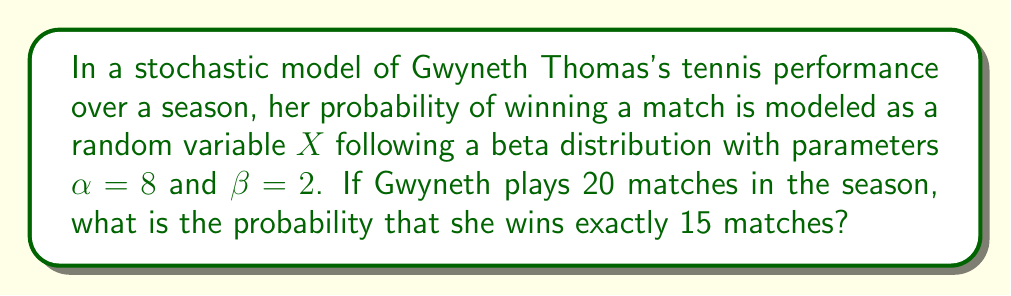Solve this math problem. To solve this problem, we need to use the concept of a beta-binomial distribution, which is a combination of the beta and binomial distributions. Here's the step-by-step solution:

1) The beta distribution models Gwyneth's probability of winning a single match. The mean of this distribution is:

   $$E[X] = \frac{\alpha}{\alpha + \beta} = \frac{8}{8 + 2} = 0.8$$

2) The number of wins in 20 matches, given the probability of winning each match, follows a binomial distribution. However, since the probability itself is a random variable, we need to use the beta-binomial distribution.

3) The probability mass function of the beta-binomial distribution is:

   $$P(Y = k) = \binom{n}{k} \frac{B(k + \alpha, n - k + \beta)}{B(\alpha, \beta)}$$

   where $B(a,b)$ is the beta function, $n$ is the number of trials, and $k$ is the number of successes.

4) In this case, $n = 20$, $k = 15$, $\alpha = 8$, and $\beta = 2$.

5) Substituting these values:

   $$P(Y = 15) = \binom{20}{15} \frac{B(15 + 8, 20 - 15 + 2)}{B(8, 2)}$$

6) Simplify:

   $$P(Y = 15) = \binom{20}{15} \frac{B(23, 7)}{B(8, 2)}$$

7) Calculate using a statistical software or calculator:

   $$P(Y = 15) \approx 0.1842$$

Thus, the probability of Gwyneth winning exactly 15 out of 20 matches is approximately 0.1842 or 18.42%.
Answer: 0.1842 